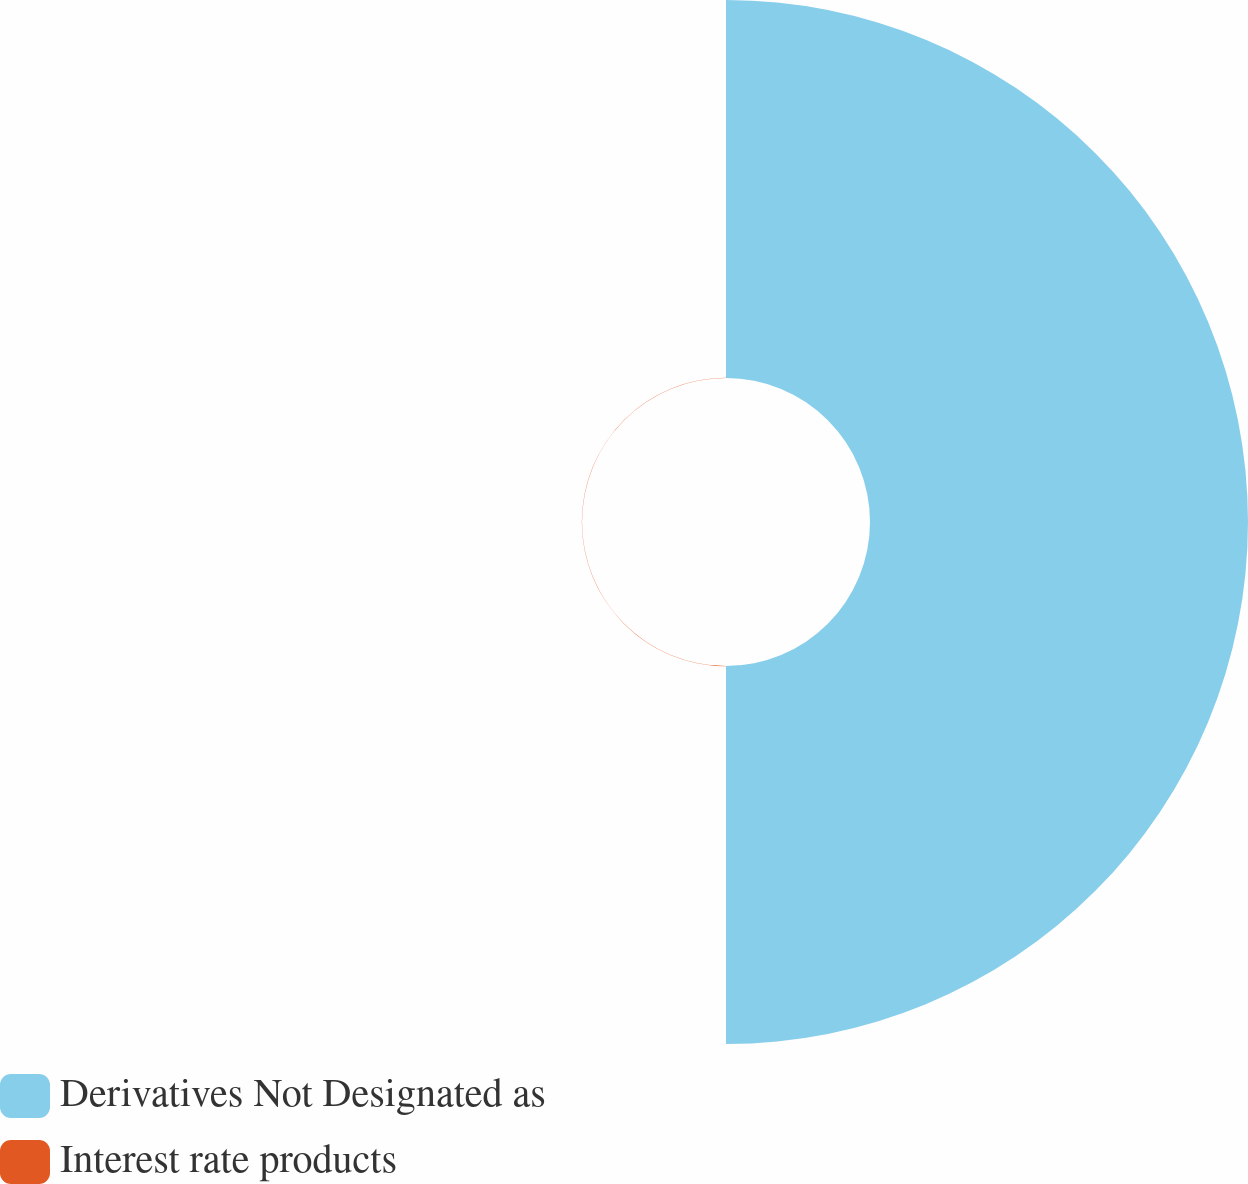<chart> <loc_0><loc_0><loc_500><loc_500><pie_chart><fcel>Derivatives Not Designated as<fcel>Interest rate products<nl><fcel>99.95%<fcel>0.05%<nl></chart> 